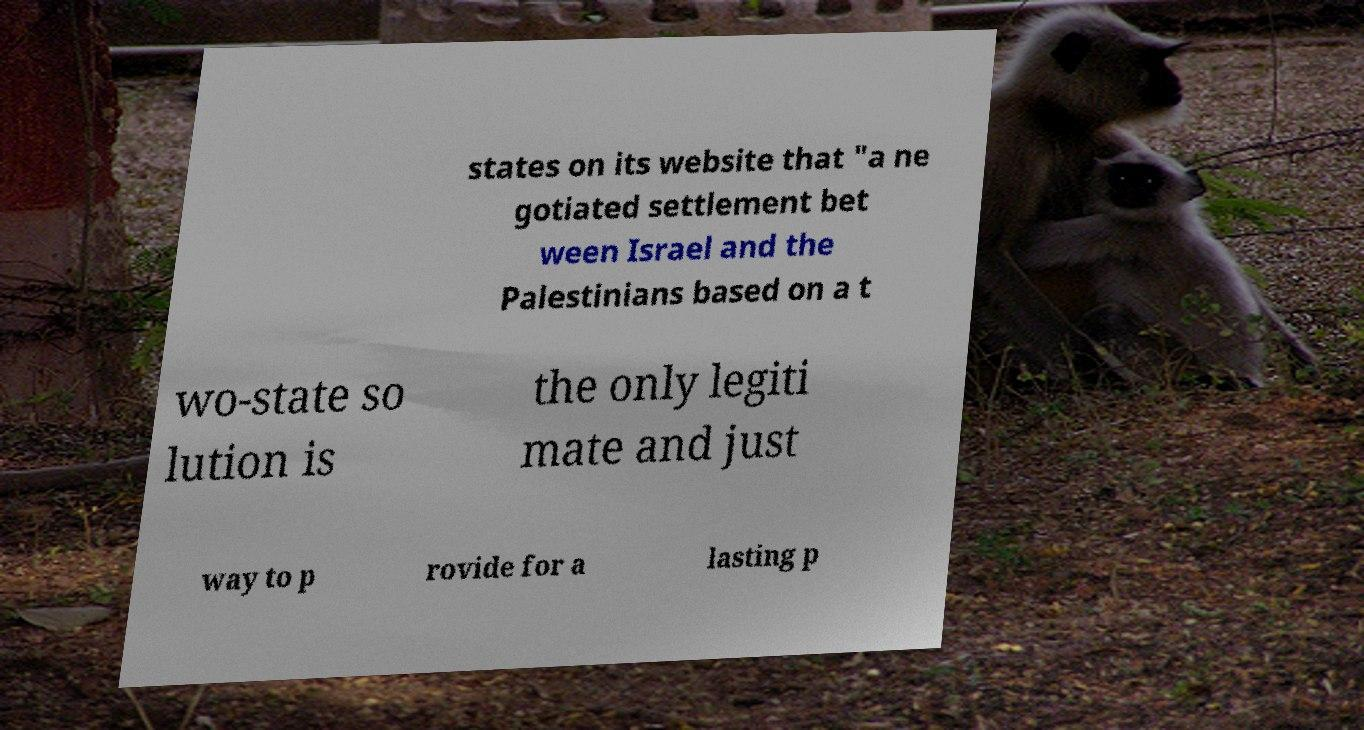Could you extract and type out the text from this image? states on its website that "a ne gotiated settlement bet ween Israel and the Palestinians based on a t wo-state so lution is the only legiti mate and just way to p rovide for a lasting p 